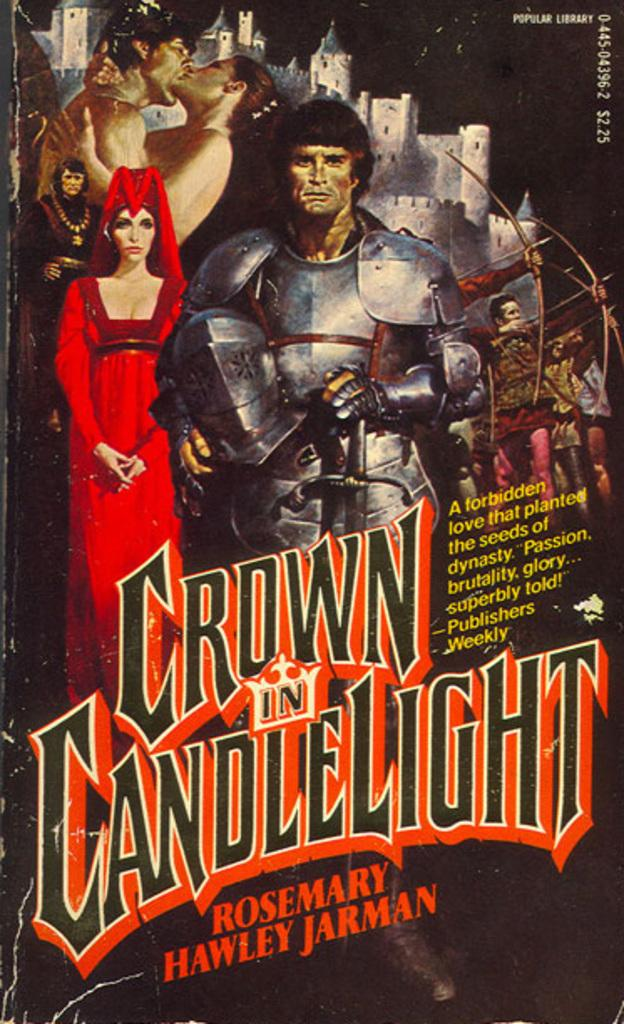What is present in the image that contains visuals and text? There is a poster in the image that contains pictures and text. Can you describe the pictures on the poster? Unfortunately, the specific pictures on the poster cannot be described without more information. What type of information is conveyed through the text on the poster? The content of the text on the poster cannot be determined without more information. What type of cracker is being weighed on the stove in the image? There is no stove, cracker, or weight present in the image. 